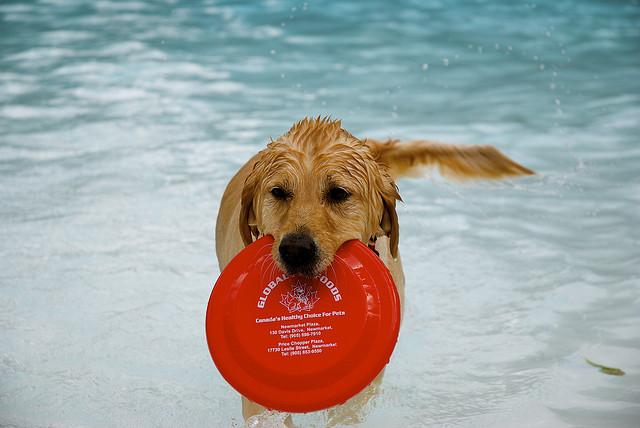Is the dog clean?
Answer briefly. Yes. What is the dog laying on?
Concise answer only. Water. What color is the frisbee?
Answer briefly. Red. What is in the dogs mouth?
Be succinct. Frisbee. Has this dog been in the water?
Concise answer only. Yes. What color is the Frisbee?
Write a very short answer. Red. 